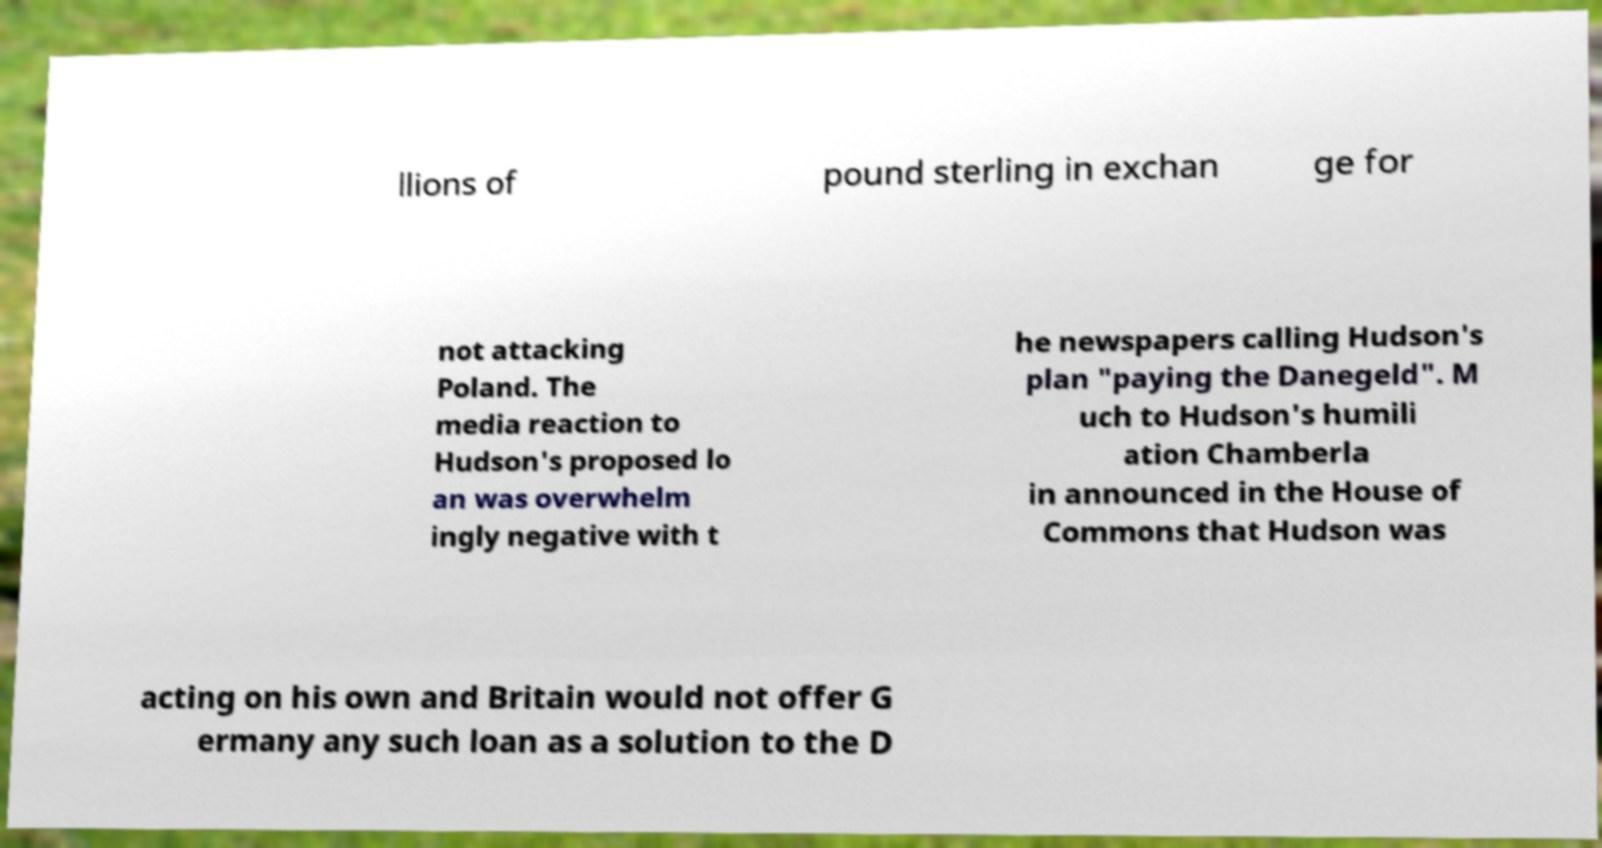Can you read and provide the text displayed in the image?This photo seems to have some interesting text. Can you extract and type it out for me? llions of pound sterling in exchan ge for not attacking Poland. The media reaction to Hudson's proposed lo an was overwhelm ingly negative with t he newspapers calling Hudson's plan "paying the Danegeld". M uch to Hudson's humili ation Chamberla in announced in the House of Commons that Hudson was acting on his own and Britain would not offer G ermany any such loan as a solution to the D 